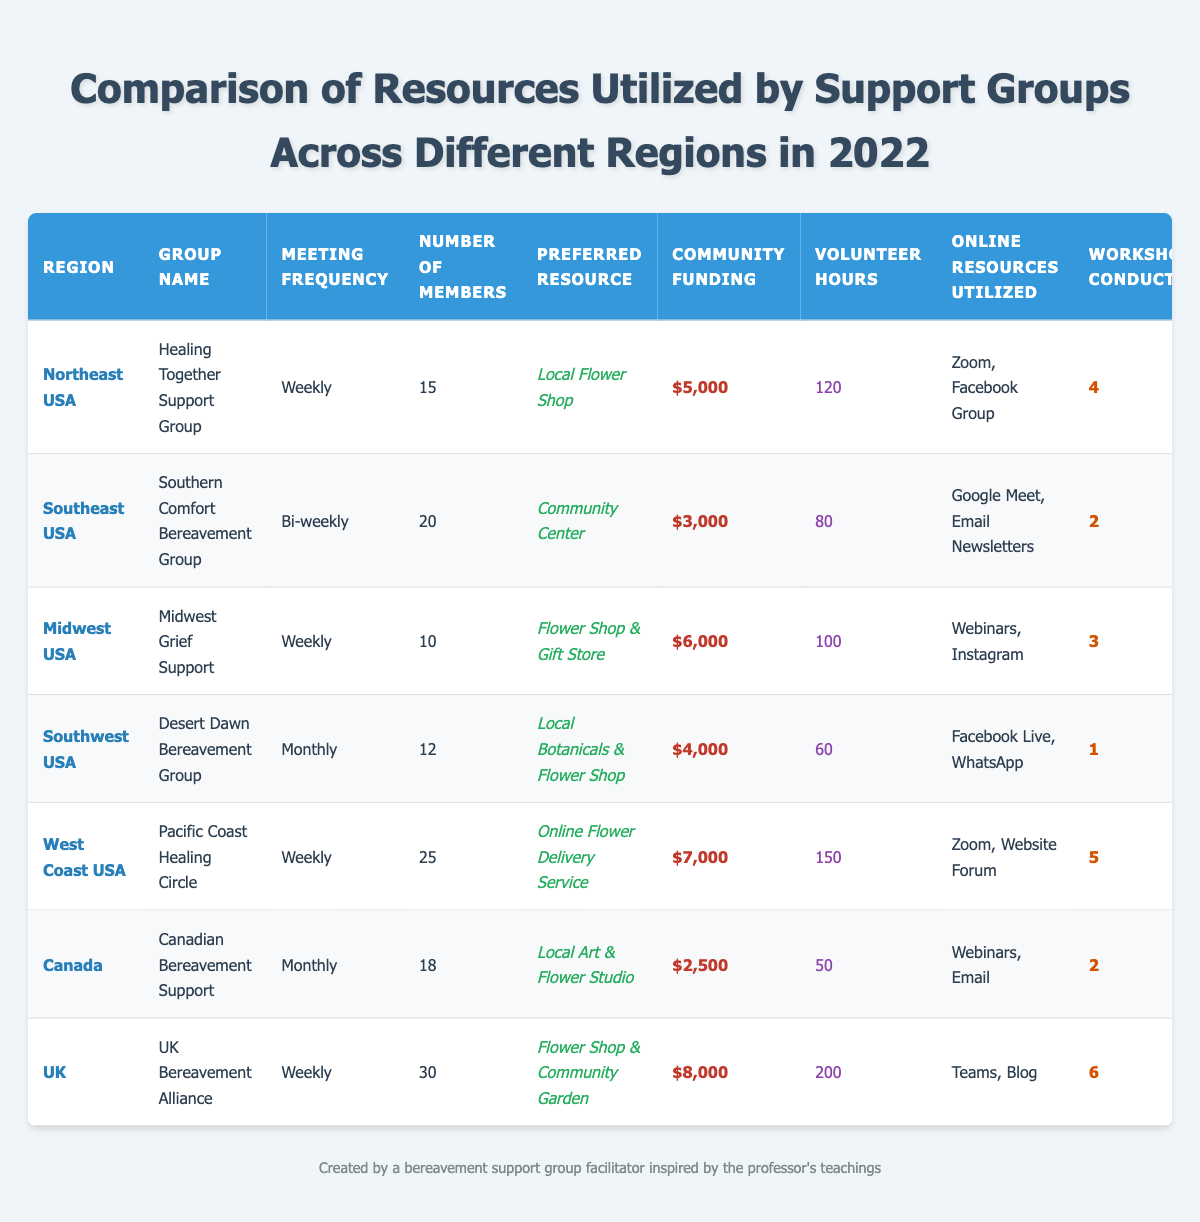What is the preferred resource for the Pacific Coast Healing Circle? The table lists "Preferred Resource" for the Pacific Coast Healing Circle under the "West Coast USA" region, which is "Online Flower Delivery Service."
Answer: Online Flower Delivery Service Which support group has the highest community funding? By comparing the values in the "Community Funding" column, the UK Bereavement Alliance has the highest amount at $8,000.
Answer: $8,000 How many workshops were conducted by the Southern Comfort Bereavement Group? The table shows that the Southern Comfort Bereavement Group conducted 2 workshops, as listed in the "Workshops Conducted" column.
Answer: 2 What is the total number of volunteer hours contributed by all support groups? To find the total, add the volunteer hours: 120 + 80 + 100 + 60 + 150 + 50 + 200 = 860.
Answer: 860 Which region has the most number of members in their support group? Looking at the "Number of Members," the UK Bereavement Alliance has the most with 30 members compared to others.
Answer: 30 Is there a support group in Canada that prefers flower-related resources? The Canadian Bereavement Support prefers "Local Art & Flower Studio," which includes flower-related resources. Thus, the answer is yes.
Answer: Yes How many support groups meet weekly? The groups that meet weekly are the Healing Together Support Group, Midwest Grief Support, Pacific Coast Healing Circle, and UK Bereavement Alliance. That makes a total of 4 support groups.
Answer: 4 What is the average community funding for the support groups? Calculate the total community funding: $5,000 + $3,000 + $6,000 + $4,000 + $7,000 + $2,500 + $8,000 = $35,500. There are 7 groups, so the average is $35,500 / 7 = $5,071.43.
Answer: $5,071.43 Which group in the Southwest USA has the least number of workshops conducted? Checking the "Workshops Conducted" for the Desert Dawn Bereavement Group shows that they conducted only 1 workshop, which is the least.
Answer: 1 How many more volunteer hours does the UK Bereavement Alliance have compared to the Desert Dawn Bereavement Group? The UK Bereavement Alliance has 200 volunteer hours while the Desert Dawn Bereavement Group has 60. The difference is 200 - 60 = 140 volunteer hours.
Answer: 140 